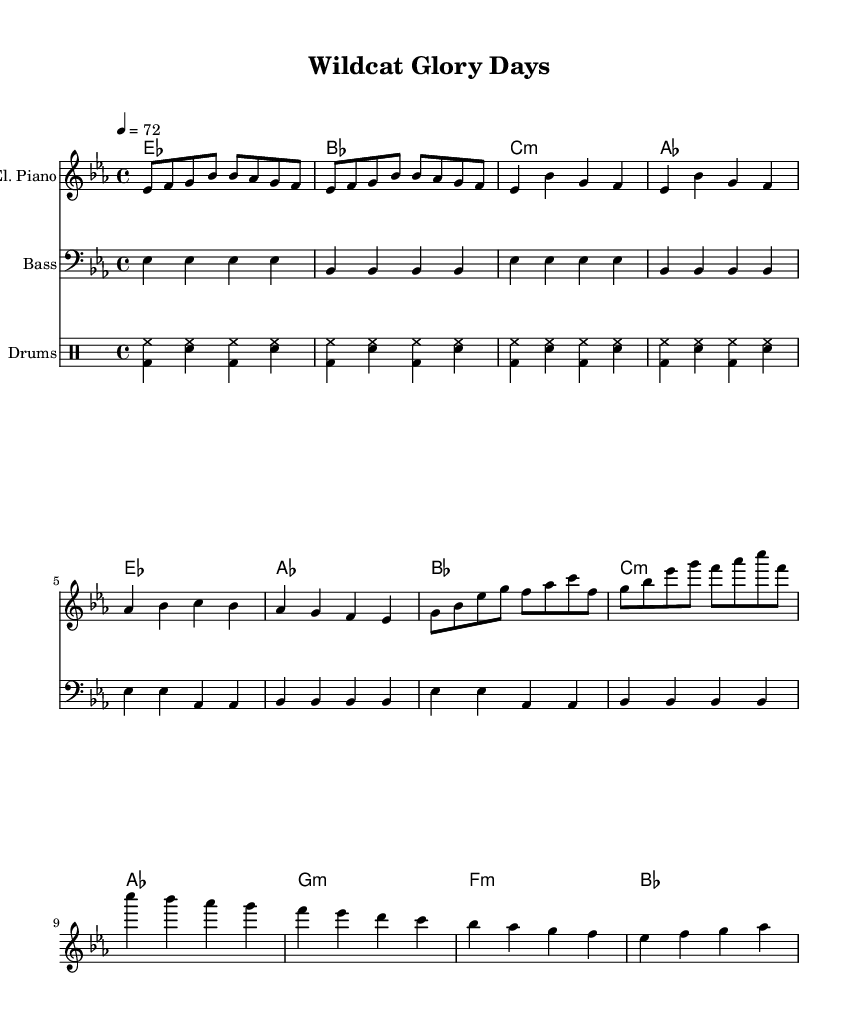What is the key signature of this music? The key signature indicated at the beginning of the score is E flat major, which has three flats (B flat, E flat, A flat).
Answer: E flat major What is the time signature of this music? The time signature is shown in the staff at the beginning, which indicates that the piece has four beats per measure.
Answer: 4/4 What is the tempo marking for this piece? The tempo is notated above the staff, given as quarter note equals seventy-two beats per minute.
Answer: 72 How many measures are in the Chorus section? By counting the measures labeled for the Chorus, we find that there are four distinct measures.
Answer: 4 What instruments are included in the score? The score lists three different instruments, which are an electric piano, bass guitar, and drums.
Answer: Electric piano, bass guitar, drums What type of musical groove is used in the drums part? The drum part features a commonly recognized rhythmic style associated with funk music known for its syncopated beats.
Answer: Funk groove What is the chord progression for the Verse section? Analyzing the chords above the music during the Verse reveals a progression of E flat, B flat, C minor, and A flat.
Answer: E flat, B flat, C minor, A flat 